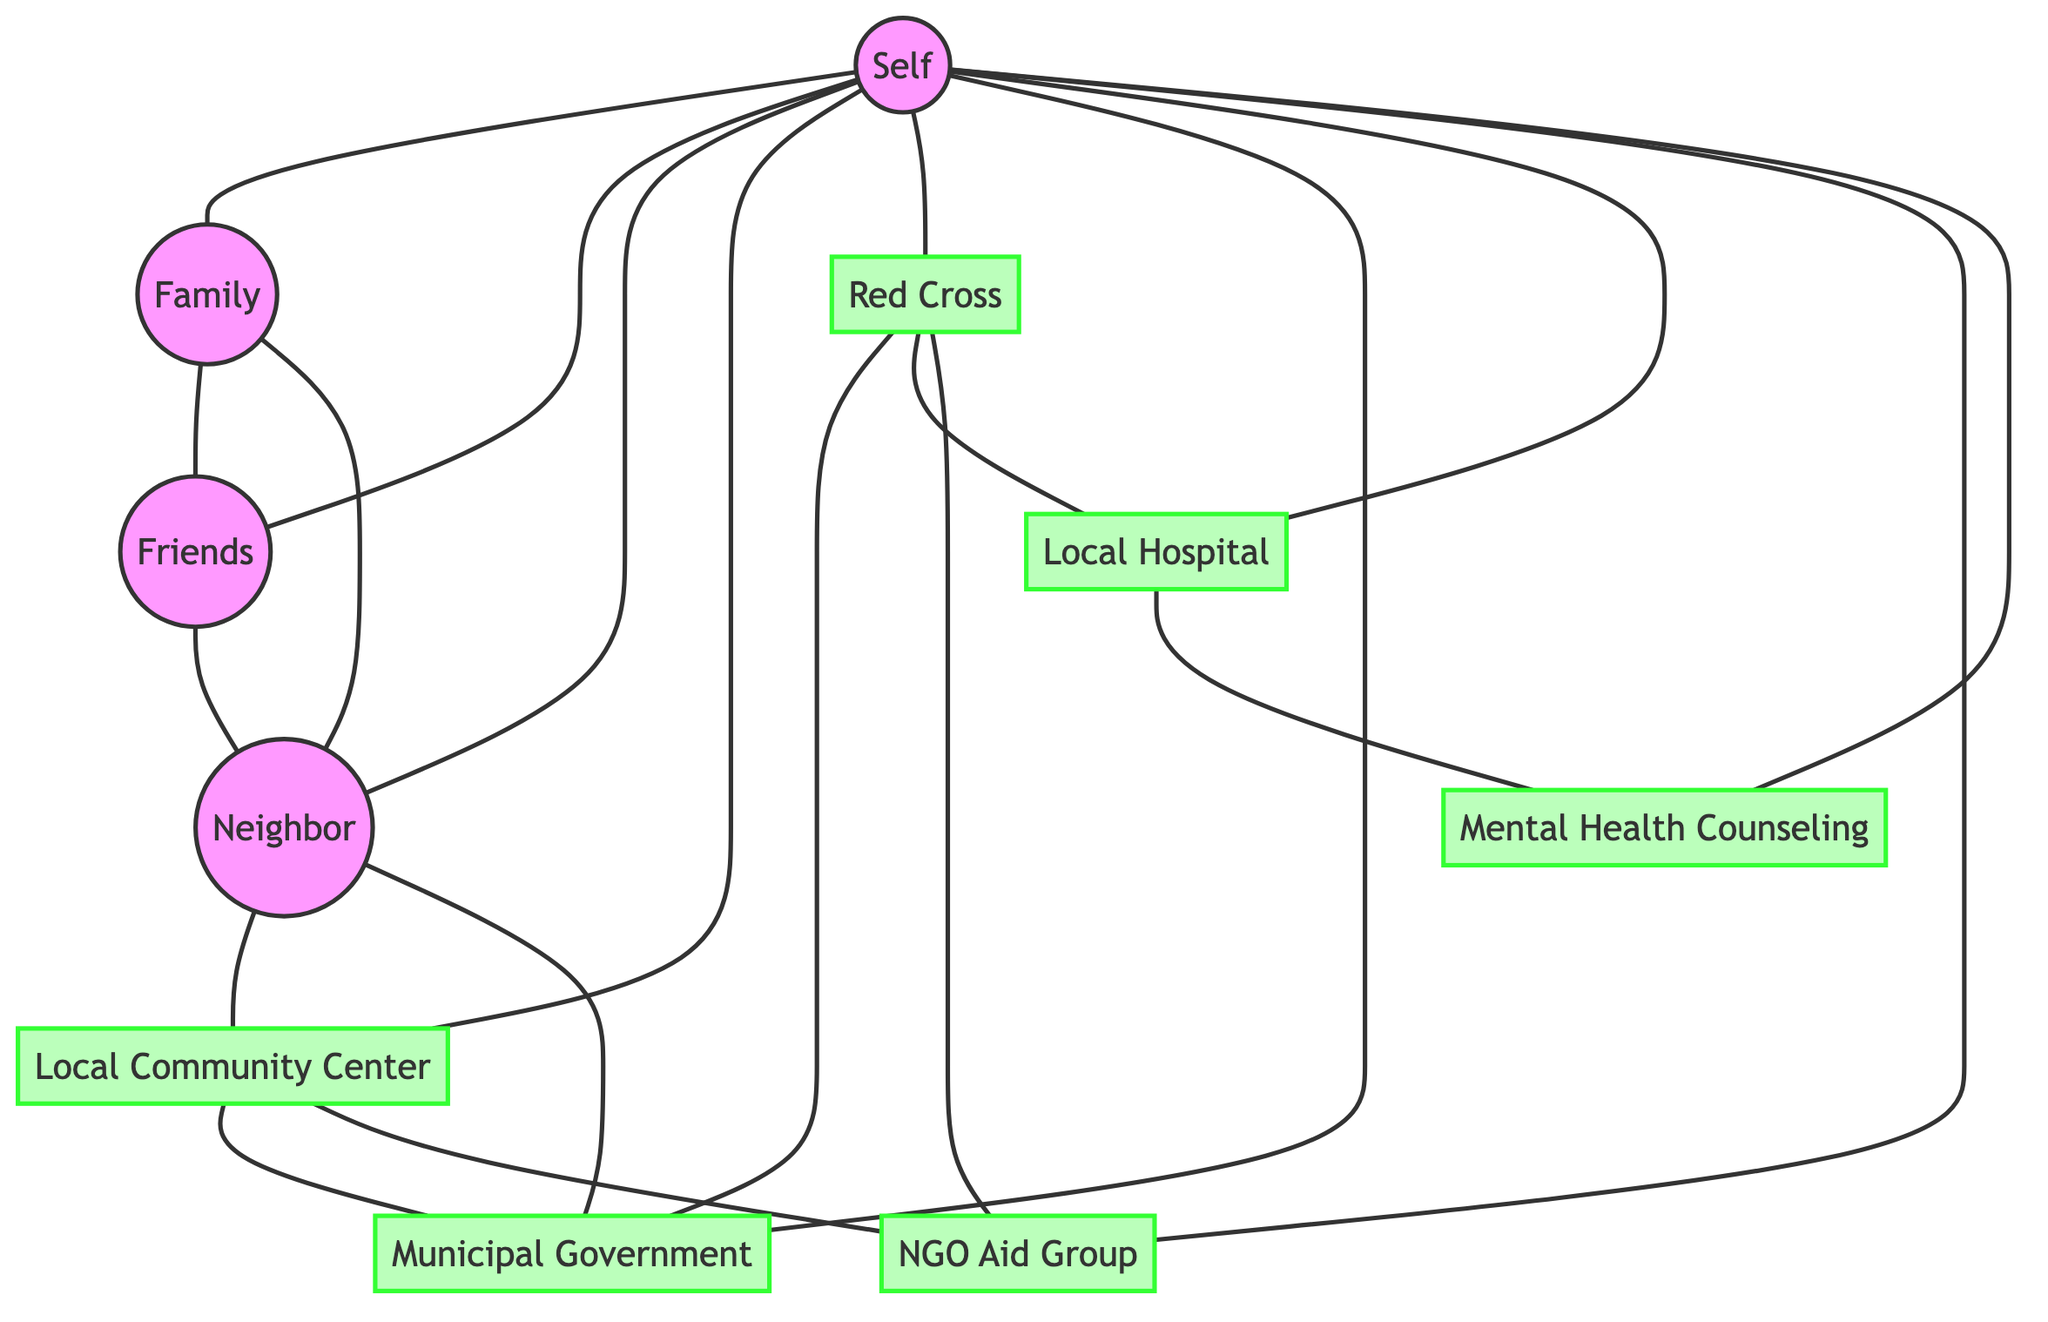What is the total number of nodes in the diagram? The diagram contains 10 distinct nodes represented in the "nodes" section of the dataset. Counting them gives us Self, Family, Friends, Neighbor, Local Community Center, Red Cross, Municipal Government, Local Hospital, NGO Aid Group, and Mental Health Counseling, which totals to 10.
Answer: 10 Which node is connected to the most other nodes? To find the node with the most connections (edges), I analyze each node's connections in the edges section. Self is connected to Family, Friends, Neighbor, Local Community Center, Red Cross, Municipal Government, Local Hospital, NGO Aid Group, and Mental Health Counseling, giving Self 9 connections, which is more than any other node.
Answer: Self How many connections does the Local Community Center have? By examining the connections listed in the edges section, I see that the Local Community Center is connected to Neighbor, Municipal Government, and NGO Aid Group. There are 3 direct connections to the Local Community Center.
Answer: 3 What type of agency is the Red Cross classified as? The Red Cross is a node in the diagram that is labeled under the "agency" class based on the class definitions provided in the code. This relationship is noted by the coloring, which is specific to support agencies.
Answer: agency How many edges connect the Family node to other nodes? To find the number of edges connecting the Family node, I look at all edges originating from Family. Family connects to Friends and Neighbor, providing a total of 2 edges that emanate from Family.
Answer: 2 Which two nodes are directly connected to both the Neighbor and the Red Cross? I check the edges for connections to both Neighbor and Red Cross. The Municipal Government connects with both Neighbor and Red Cross, as listed in the edges. Neither of those two nodes has more connections to others shared directly with both Neighbor and Red Cross.
Answer: Municipal Government What is the relationship between the Local Hospital and Mental Health Counseling nodes? The edge between Local Hospital and Mental Health Counseling indicates a connection, showing that Mental Health Counseling is a service associated with the Local Hospital. The relationship describes a direct line between the two nodes in the context of support services.
Answer: connected How many support agencies are identified in the diagram? By identifying nodes marked as agencies, I focus on those within the "agency" class. These include Local Community Center, Red Cross, Municipal Government, Local Hospital, and NGO Aid Group. There are 5 nodes that qualify as support agencies.
Answer: 5 Which nodes are connected to both the Self and Neighbor nodes? To identify the nodes that connect to both Self and Neighbor, I analyze each node. Family and Friends are connected to Self and Neighbor, meeting both conditions described. This means they appear as connections to both nodes.
Answer: Family, Friends 